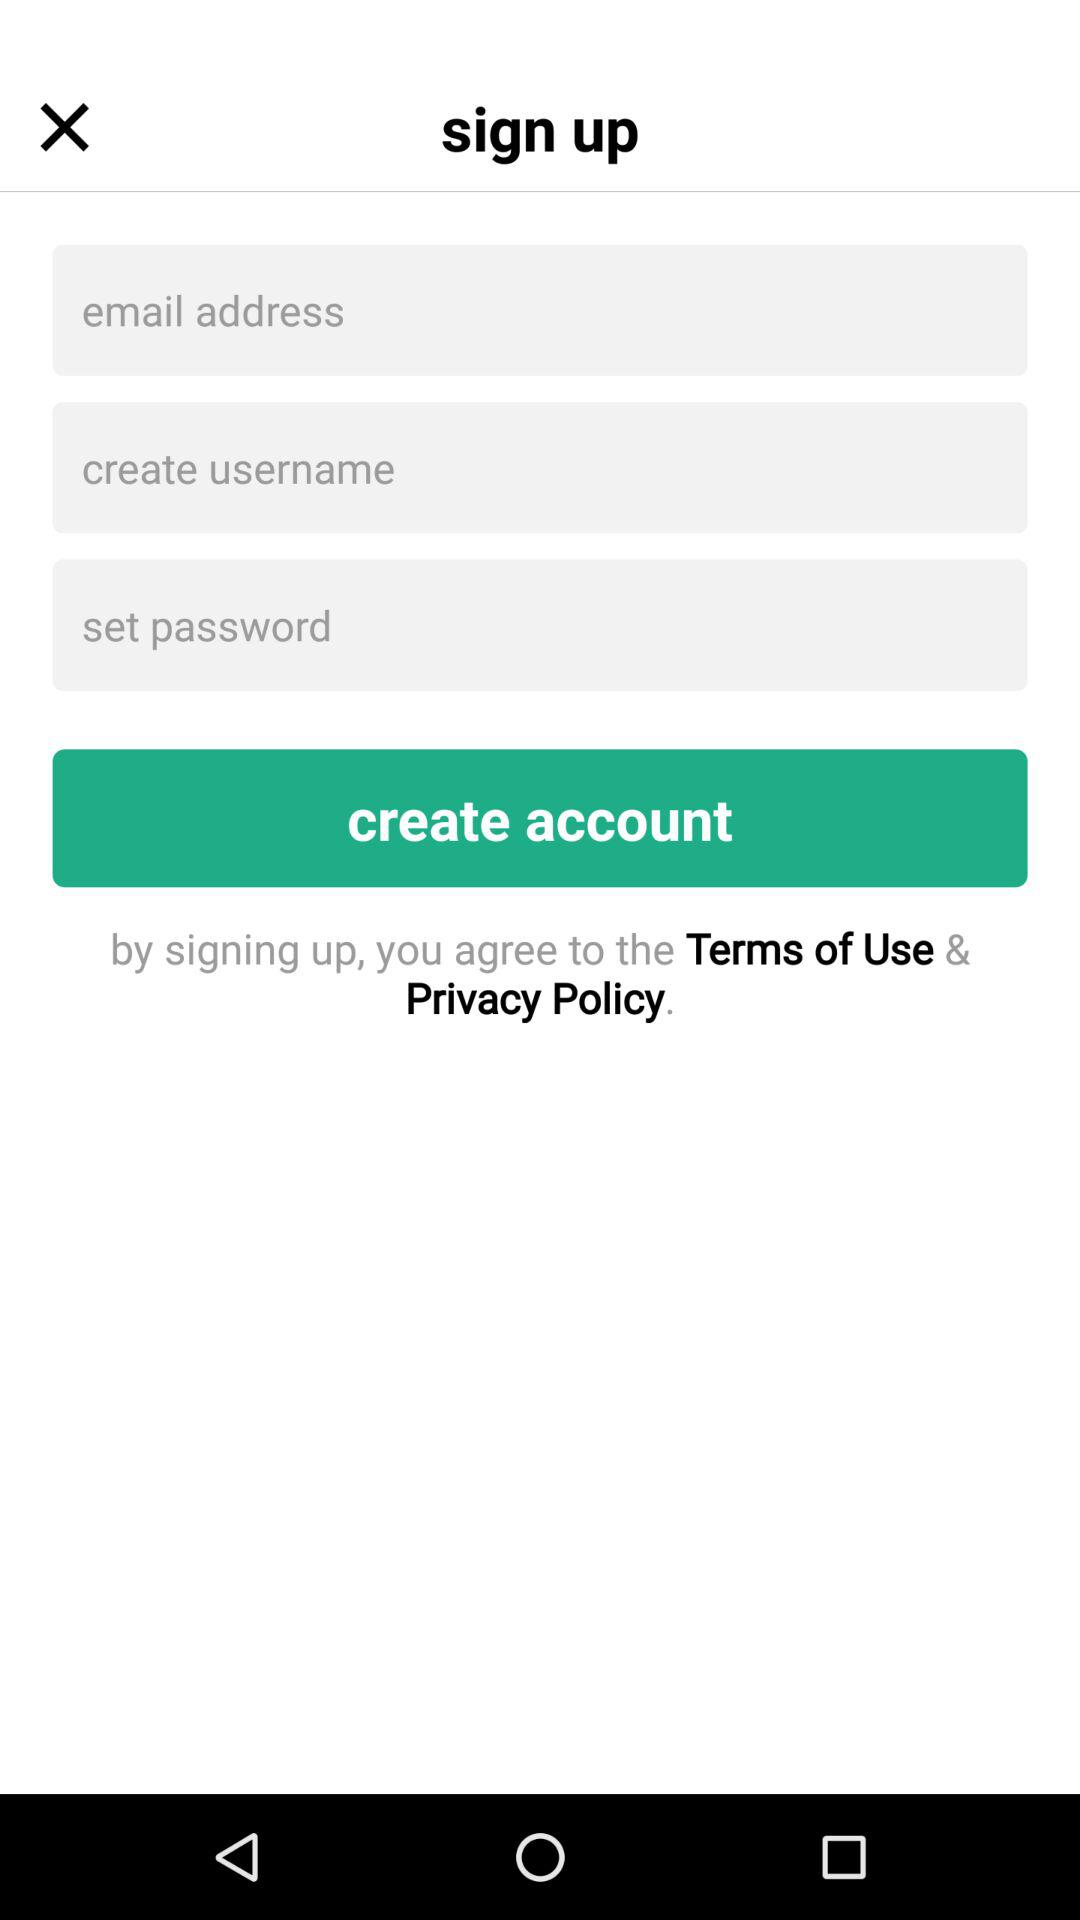How many text inputs are on the sign up screen?
Answer the question using a single word or phrase. 3 